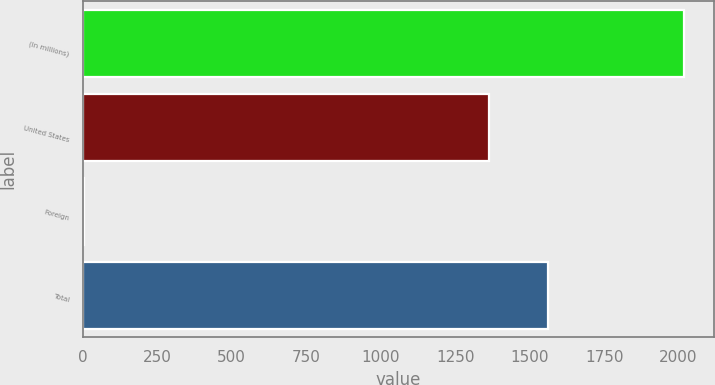Convert chart. <chart><loc_0><loc_0><loc_500><loc_500><bar_chart><fcel>(In millions)<fcel>United States<fcel>Foreign<fcel>Total<nl><fcel>2017<fcel>1362<fcel>5<fcel>1563.2<nl></chart> 